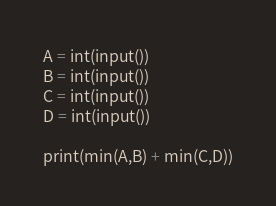<code> <loc_0><loc_0><loc_500><loc_500><_Python_>A = int(input())
B = int(input())
C = int(input())
D = int(input())

print(min(A,B) + min(C,D))</code> 